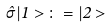<formula> <loc_0><loc_0><loc_500><loc_500>\hat { \sigma } | 1 > \, \colon = | 2 ></formula> 